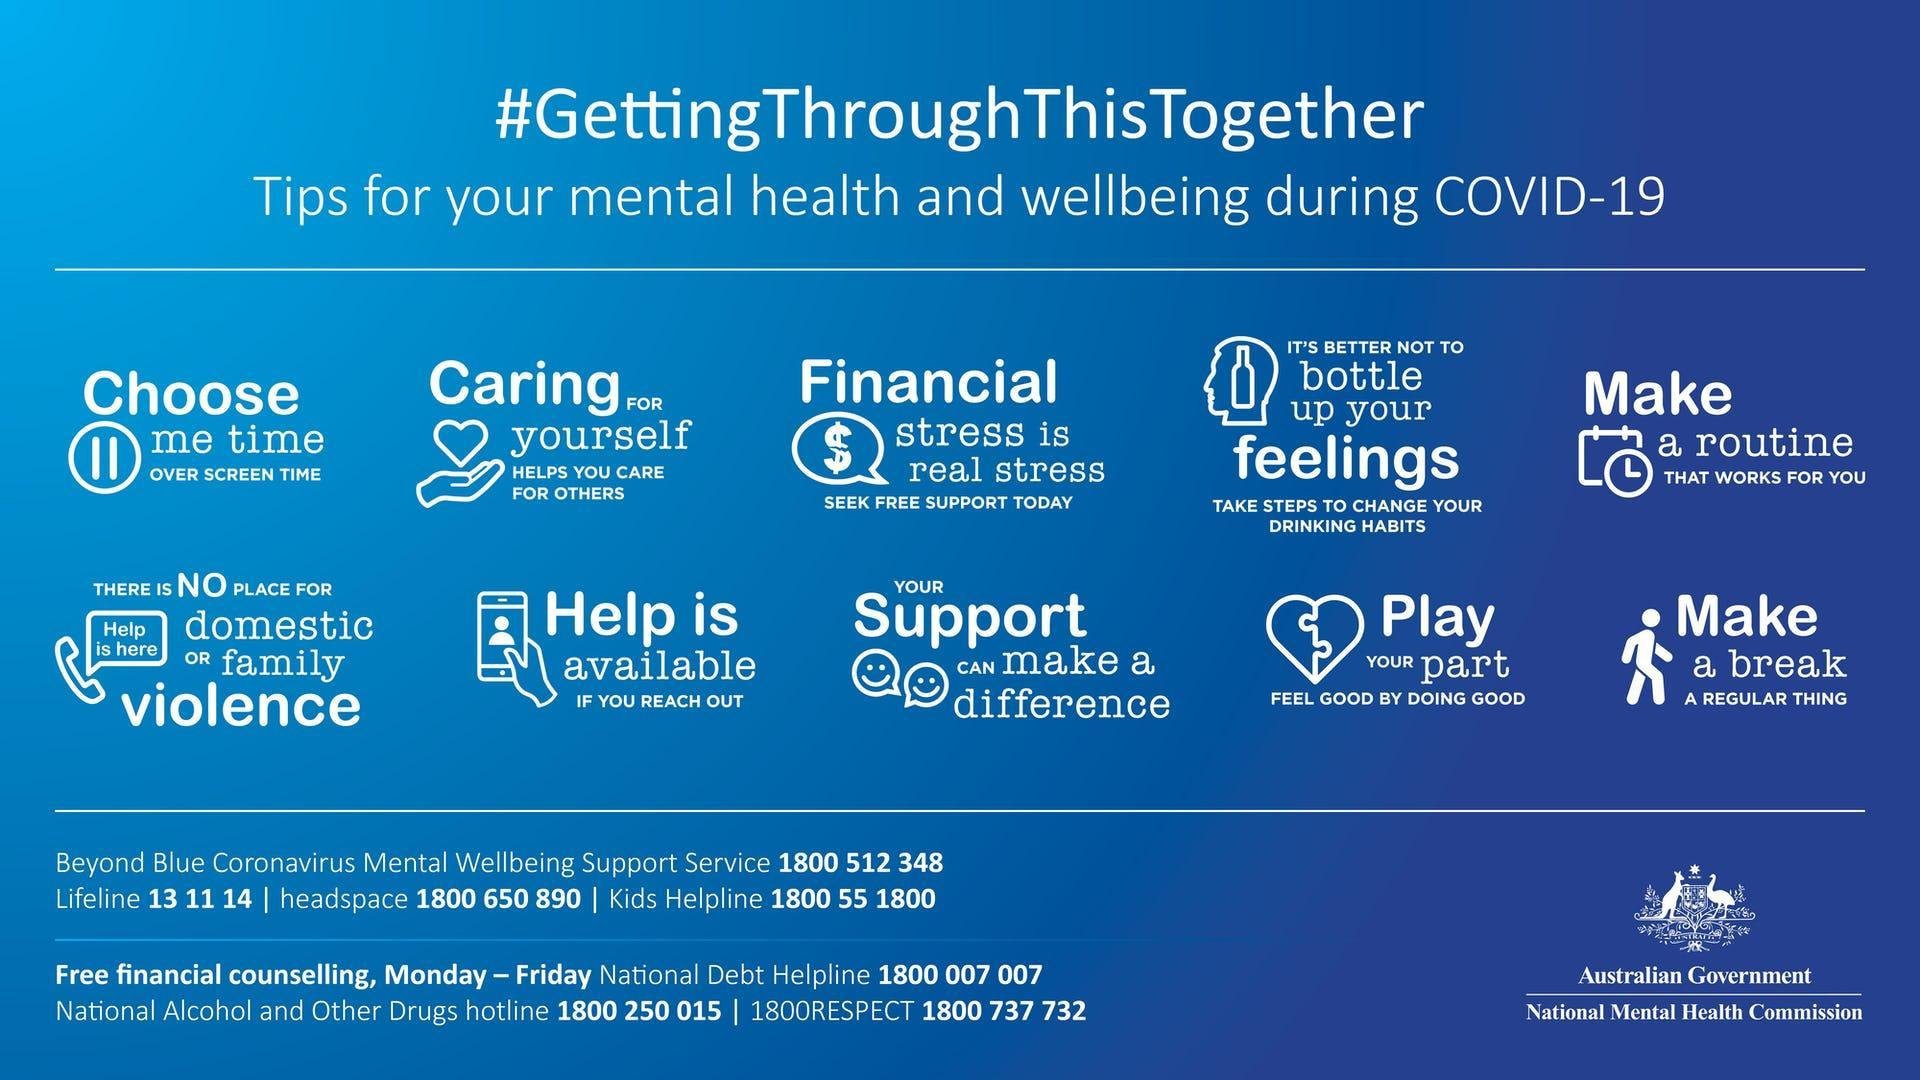How many tips for mental health and well being against COVID 19 are mentioned in the info graphic?
Answer the question with a short phrase. 10 What is the sixth tip mentioned in the info graphic? There is no place for domestic or family violence What is the fifth tip mentioned in the info graphic? Make a routine that works for you 